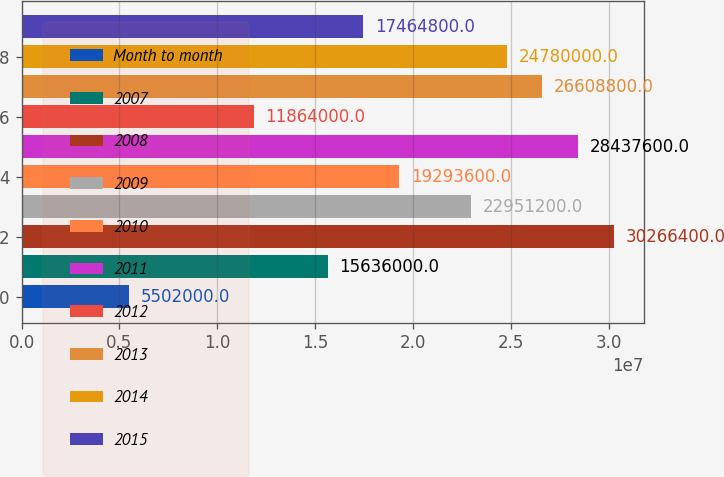Convert chart. <chart><loc_0><loc_0><loc_500><loc_500><bar_chart><fcel>Month to month<fcel>2007<fcel>2008<fcel>2009<fcel>2010<fcel>2011<fcel>2012<fcel>2013<fcel>2014<fcel>2015<nl><fcel>5.502e+06<fcel>1.5636e+07<fcel>3.02664e+07<fcel>2.29512e+07<fcel>1.92936e+07<fcel>2.84376e+07<fcel>1.1864e+07<fcel>2.66088e+07<fcel>2.478e+07<fcel>1.74648e+07<nl></chart> 